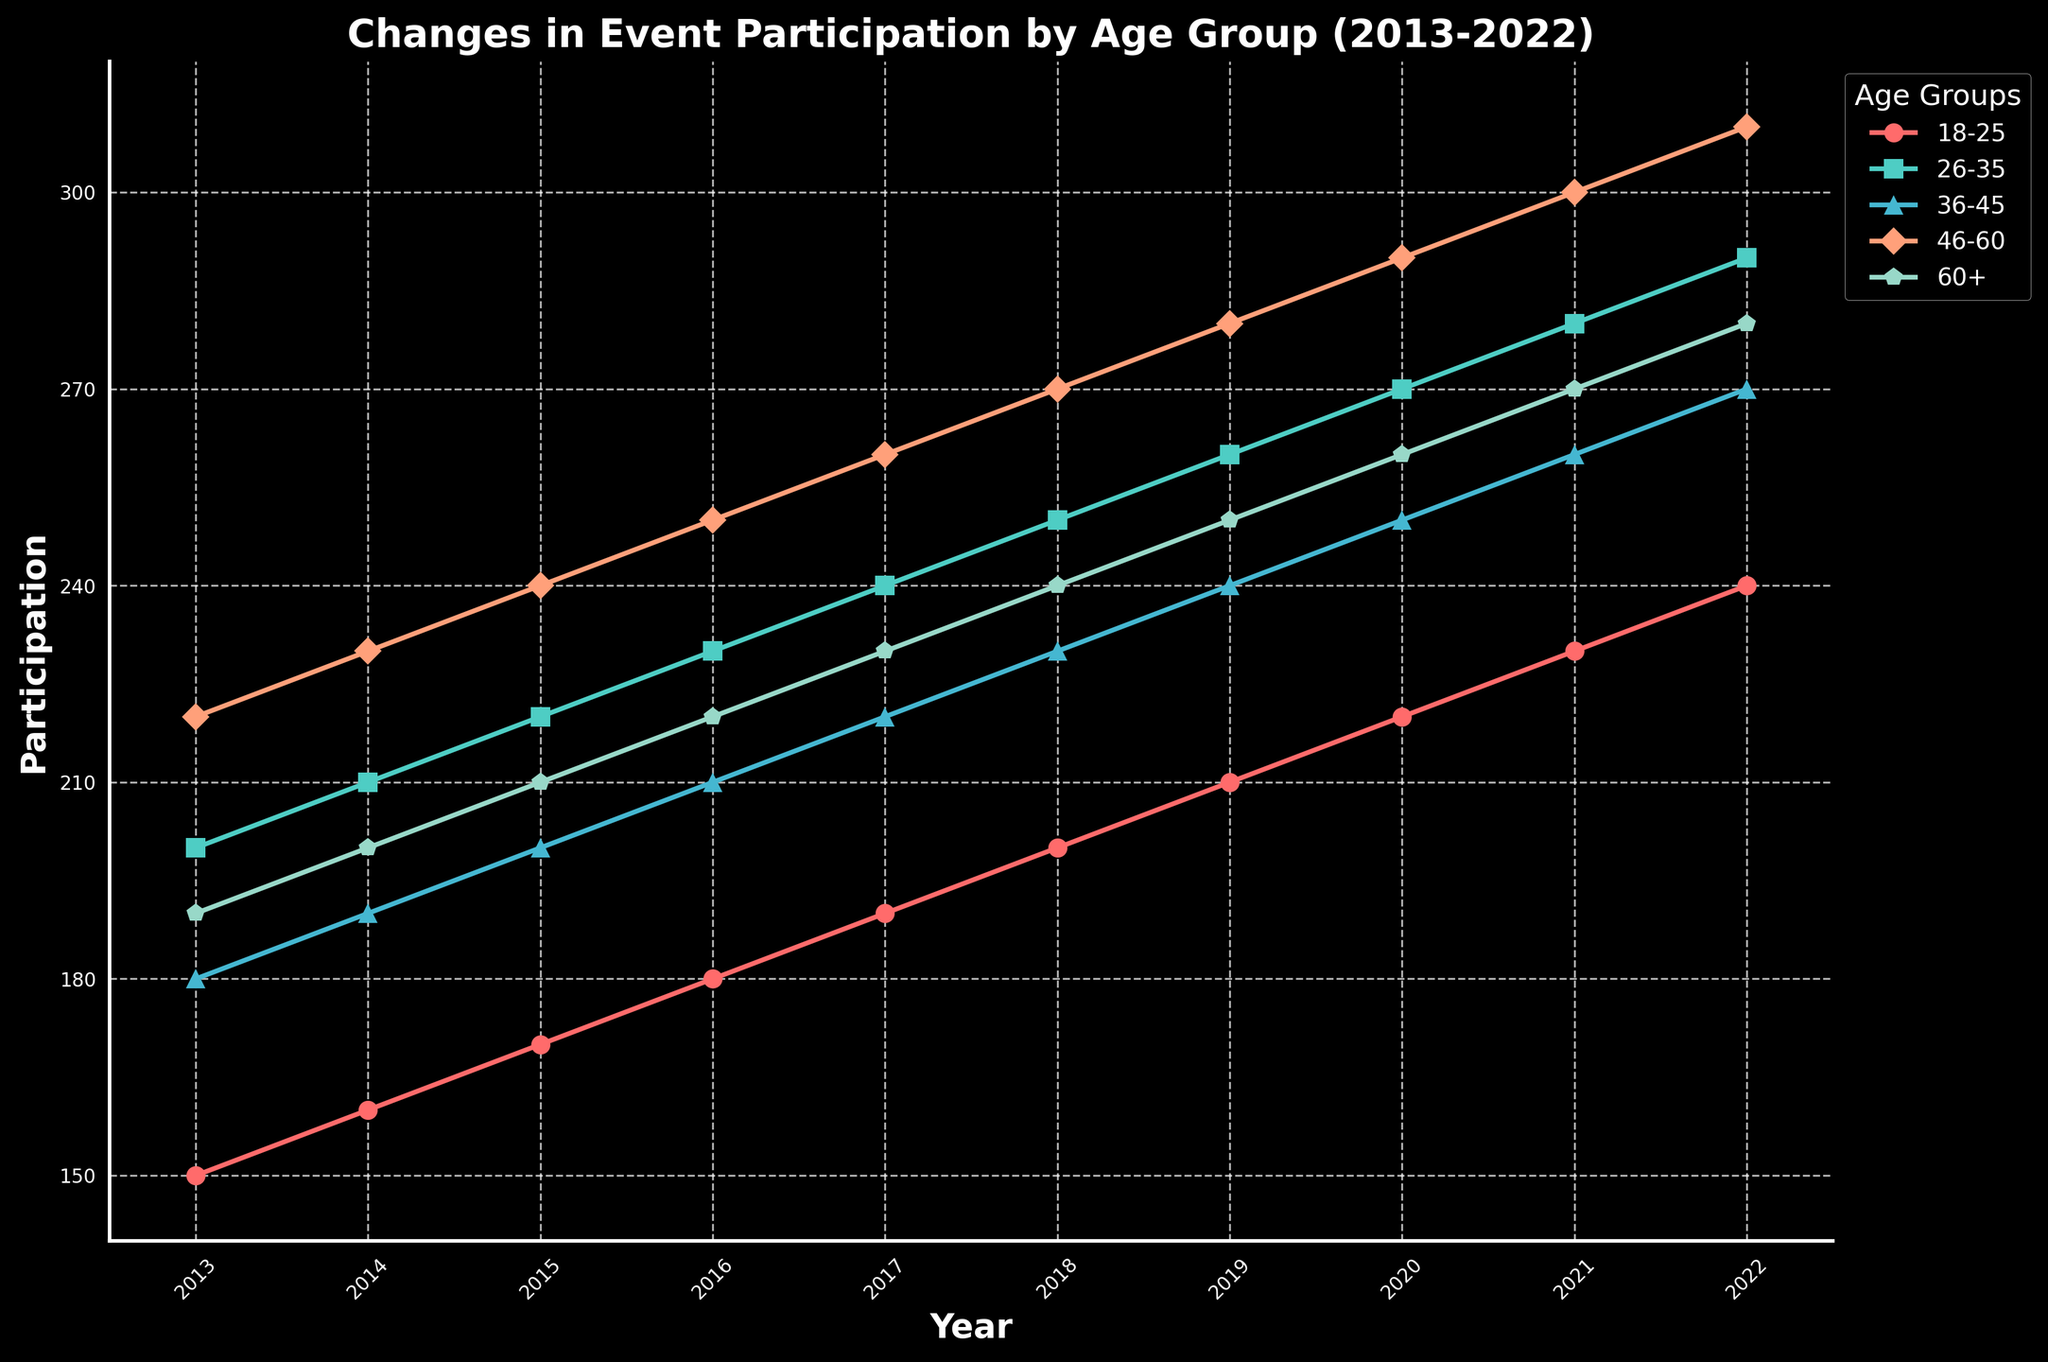How many age groups are depicted in the plot? The plot has multiple lines, each representing a different age group. By counting the distinct lines, one can identify the number of age groups depicted.
Answer: 5 What is the title of the plot? The title of a plot is typically displayed at the top. Read the text located there to identify the title.
Answer: Changes in Event Participation by Age Group (2013-2022) Which age group experienced the highest participation in 2013? Look at the values at the 2013 mark on the x-axis for each age group, and then identify the age group with the highest value.
Answer: Age Group 46-60 Between which years did the age group 18-25 see the most significant increase? Examine the line representing the 18-25 age group and compare the differences in participation values between consecutive years. The largest increase will be the steepest upward slope in the graph.
Answer: 2021 to 2022 What is the average participation for the age group 60+ over the entire period? To find the average, sum the participation values for the age group 60+ from 2013 to 2022 and divide by the number of years (10).
Answer: 235 Which age group showed the most consistent increase in participation over the decade? Identify the age group whose line on the plot shows a steady upward trend without large fluctuations.
Answer: Age Group 18-25 How much did the participation in the age group 26-35 increase from 2015 to 2020? Locate the participation values for the age group 26-35 in 2015 and 2020 on the y-axis, then subtract the 2015 value from the 2020 value.
Answer: 50 In what year did the age group 36-45 surpass a participation level of 250? Follow the line representing the age group 36-45 and identify the first year where the value on the y-axis exceeds 250.
Answer: 2020 Compare the participation trend of 18-25 and 46-60 age groups. Which one increased more rapidly? Examine the slopes of the lines for both age groups throughout the period and determine which has a steeper overall upward slope.
Answer: Age Group 18-25 Is there any year where the participation of all age groups is above 200? Check the lines for all age groups across each year and identify if there is any year where all lines are above the 200 mark on the y-axis.
Answer: 2022 